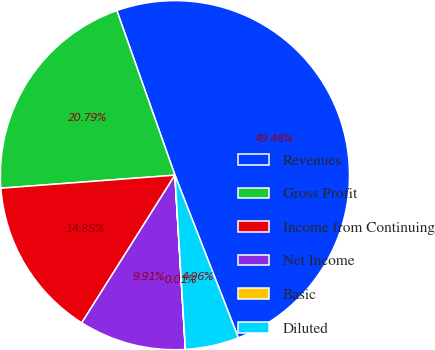<chart> <loc_0><loc_0><loc_500><loc_500><pie_chart><fcel>Revenues<fcel>Gross Profit<fcel>Income from Continuing<fcel>Net Income<fcel>Basic<fcel>Diluted<nl><fcel>49.48%<fcel>20.79%<fcel>14.85%<fcel>9.91%<fcel>0.01%<fcel>4.96%<nl></chart> 